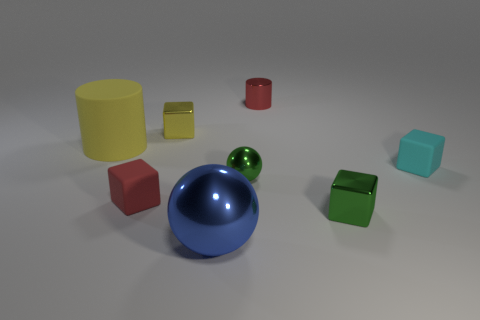There is a tiny metallic thing in front of the tiny red cube; is its color the same as the small sphere?
Keep it short and to the point. Yes. What is the material of the object that is the same color as the tiny sphere?
Your answer should be very brief. Metal. How many other brown spheres have the same material as the tiny ball?
Ensure brevity in your answer.  0. There is a shiny object that is in front of the red cube and left of the tiny red metallic thing; what is its shape?
Offer a very short reply. Sphere. Does the tiny ball that is in front of the small yellow shiny block have the same material as the blue thing?
Keep it short and to the point. Yes. There is a ball that is the same size as the red shiny cylinder; what color is it?
Ensure brevity in your answer.  Green. Is there a large metallic thing of the same color as the big matte object?
Offer a very short reply. No. There is a yellow cylinder that is the same material as the cyan cube; what is its size?
Give a very brief answer. Large. How many other things are the same size as the green ball?
Keep it short and to the point. 5. What is the material of the red object to the right of the blue object?
Your answer should be very brief. Metal. 